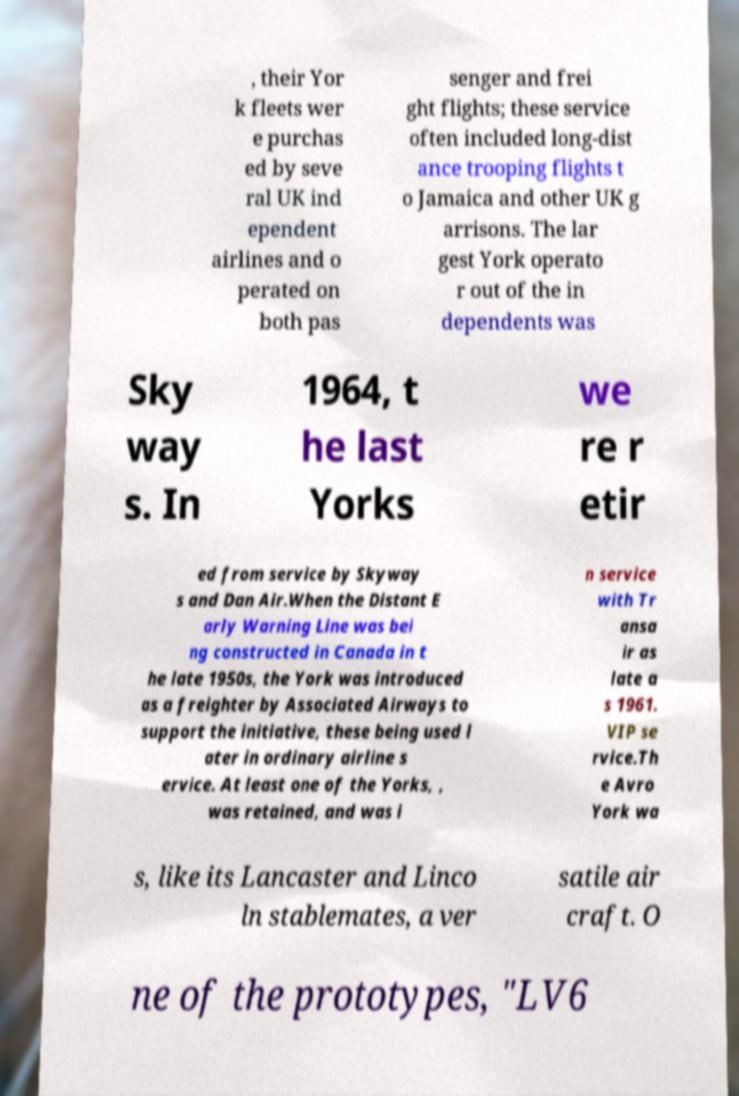Please read and relay the text visible in this image. What does it say? , their Yor k fleets wer e purchas ed by seve ral UK ind ependent airlines and o perated on both pas senger and frei ght flights; these service often included long-dist ance trooping flights t o Jamaica and other UK g arrisons. The lar gest York operato r out of the in dependents was Sky way s. In 1964, t he last Yorks we re r etir ed from service by Skyway s and Dan Air.When the Distant E arly Warning Line was bei ng constructed in Canada in t he late 1950s, the York was introduced as a freighter by Associated Airways to support the initiative, these being used l ater in ordinary airline s ervice. At least one of the Yorks, , was retained, and was i n service with Tr ansa ir as late a s 1961. VIP se rvice.Th e Avro York wa s, like its Lancaster and Linco ln stablemates, a ver satile air craft. O ne of the prototypes, "LV6 